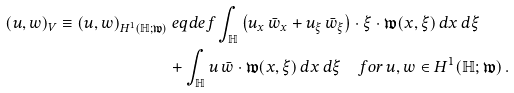Convert formula to latex. <formula><loc_0><loc_0><loc_500><loc_500>( u , w ) _ { V } \equiv ( u , w ) _ { H ^ { 1 } ( \mathbb { H } ; \mathfrak { w } ) } & \ e q d e f \int _ { \mathbb { H } } \left ( u _ { x } \, \bar { w } _ { x } + u _ { \xi } \, \bar { w } _ { \xi } \right ) \cdot \xi \cdot \mathfrak { w } ( x , \xi ) \, d x \, d \xi \\ & + \int _ { \mathbb { H } } u \, \bar { w } \cdot \mathfrak { w } ( x , \xi ) \, d x \, d \xi \quad f o r \, u , w \in H ^ { 1 } ( \mathbb { H } ; \mathfrak { w } ) \, .</formula> 